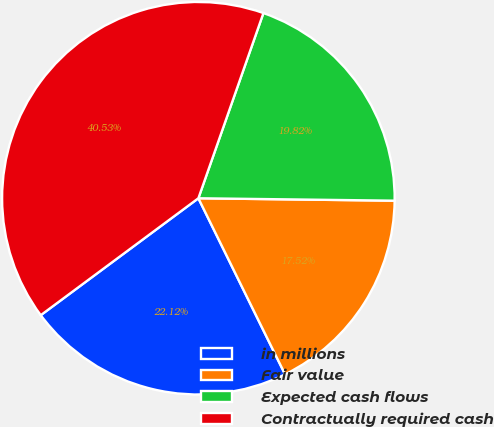<chart> <loc_0><loc_0><loc_500><loc_500><pie_chart><fcel>in millions<fcel>Fair value<fcel>Expected cash flows<fcel>Contractually required cash<nl><fcel>22.12%<fcel>17.52%<fcel>19.82%<fcel>40.53%<nl></chart> 